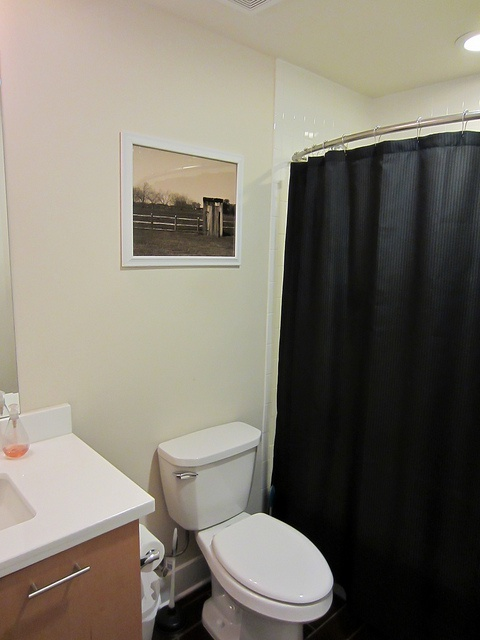Describe the objects in this image and their specific colors. I can see toilet in tan, darkgray, lightgray, and gray tones, sink in tan, lightgray, and darkgray tones, and bottle in tan, darkgray, and salmon tones in this image. 